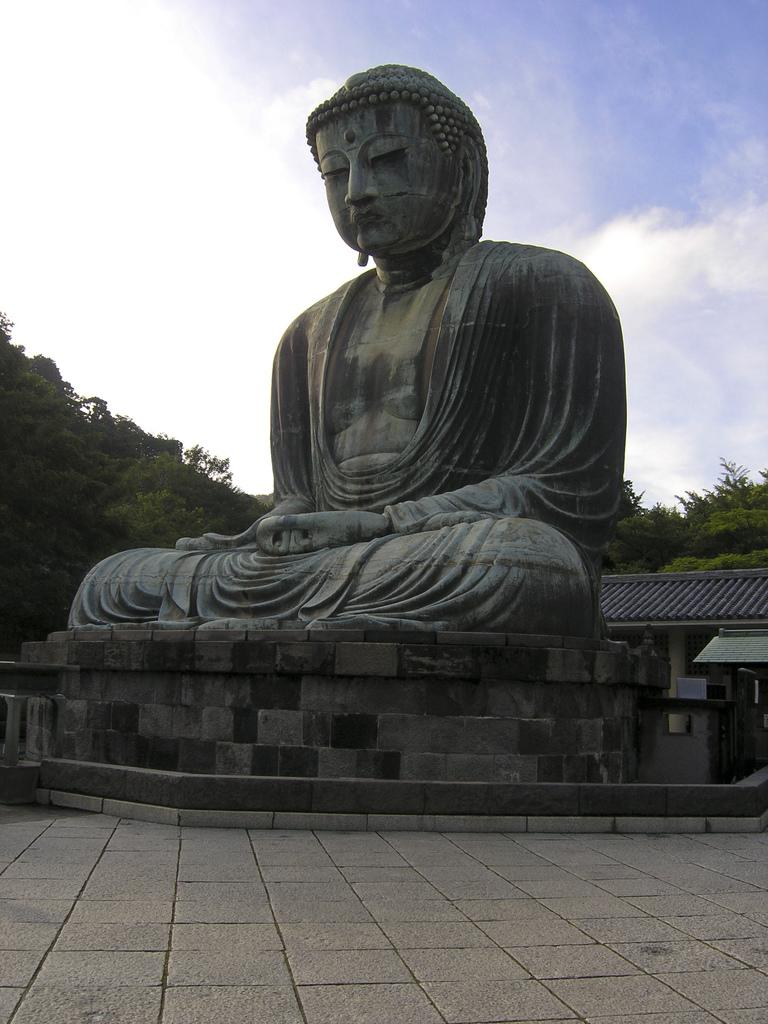What is the main subject in the center of the image? There is a stone in the center of the image. What is on top of the stone? There is a statue on the stone. What can be seen in the background of the image? The sky, clouds, trees, and at least one building are visible in the background of the image. Are there any architectural features in the background? Yes, there is a fence in the background of the image. What type of nation is depicted in the image? There is no nation depicted in the image; it features a stone with a statue on top and a background with sky, clouds, trees, and a building. How does the behavior of the statue change throughout the day in the image? The image is a still photograph, so the statue's behavior does not change throughout the day. 